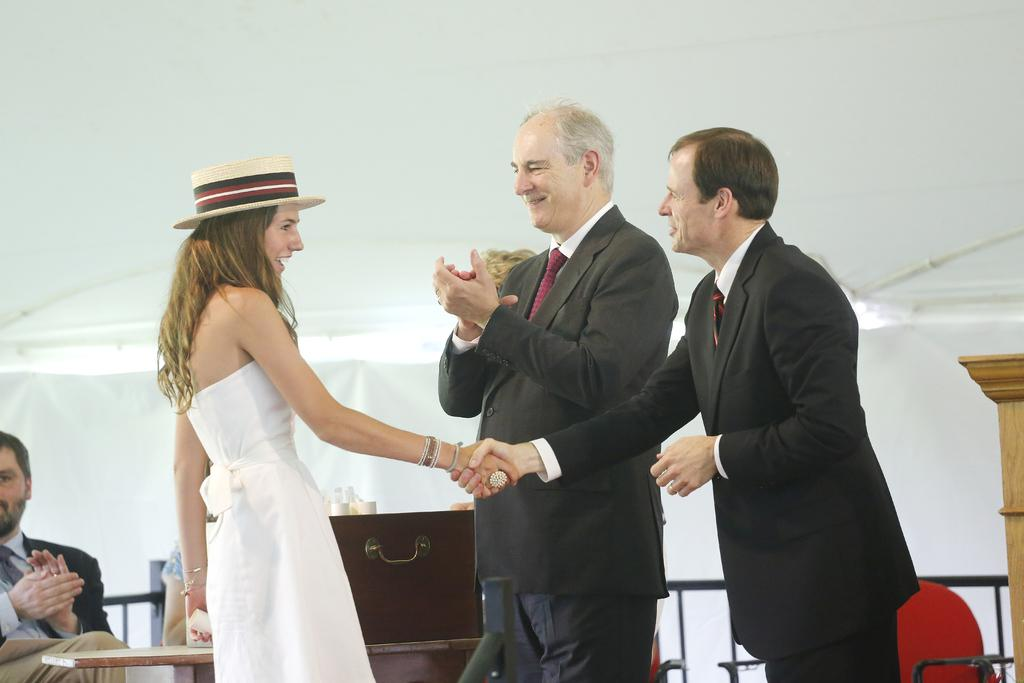What are the people in the image wearing? The persons in the image are wearing clothes. What action are two of the persons performing in the image? Two persons are shaking hands in the middle of the image. What object can be seen on a table in the image? There is a box on a table in the image. What type of tooth is visible in the image? There is no tooth visible in the image. Is there a scarecrow present in the image? No, there is no scarecrow present in the image. 